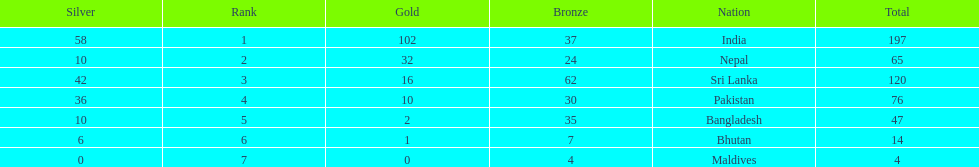Identify a nation mentioned in the chart, excluding india? Nepal. 